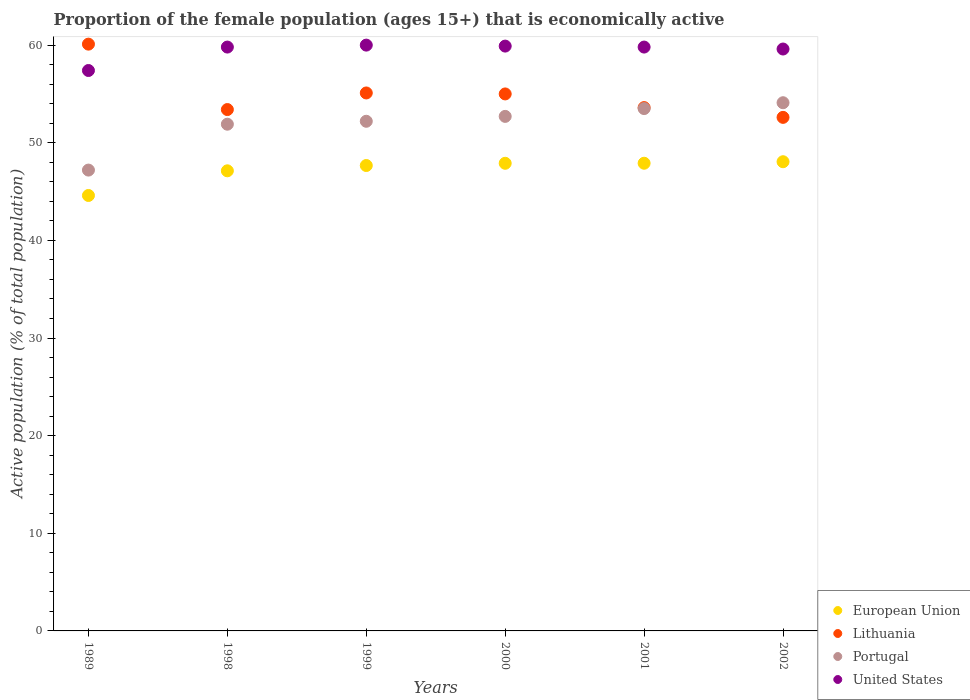Is the number of dotlines equal to the number of legend labels?
Offer a terse response. Yes. What is the proportion of the female population that is economically active in Lithuania in 2000?
Your answer should be compact. 55. Across all years, what is the minimum proportion of the female population that is economically active in Lithuania?
Your response must be concise. 52.6. In which year was the proportion of the female population that is economically active in European Union minimum?
Your response must be concise. 1989. What is the total proportion of the female population that is economically active in Portugal in the graph?
Your answer should be compact. 311.6. What is the difference between the proportion of the female population that is economically active in European Union in 1999 and that in 2000?
Give a very brief answer. -0.23. What is the difference between the proportion of the female population that is economically active in Portugal in 2001 and the proportion of the female population that is economically active in European Union in 2000?
Ensure brevity in your answer.  5.6. What is the average proportion of the female population that is economically active in European Union per year?
Keep it short and to the point. 47.21. In the year 2000, what is the difference between the proportion of the female population that is economically active in Portugal and proportion of the female population that is economically active in Lithuania?
Provide a succinct answer. -2.3. What is the ratio of the proportion of the female population that is economically active in United States in 1989 to that in 2002?
Offer a very short reply. 0.96. What is the difference between the highest and the second highest proportion of the female population that is economically active in Portugal?
Keep it short and to the point. 0.6. What is the difference between the highest and the lowest proportion of the female population that is economically active in Portugal?
Your response must be concise. 6.9. Is it the case that in every year, the sum of the proportion of the female population that is economically active in Lithuania and proportion of the female population that is economically active in United States  is greater than the sum of proportion of the female population that is economically active in Portugal and proportion of the female population that is economically active in European Union?
Ensure brevity in your answer.  No. Is it the case that in every year, the sum of the proportion of the female population that is economically active in European Union and proportion of the female population that is economically active in Portugal  is greater than the proportion of the female population that is economically active in Lithuania?
Your answer should be compact. Yes. Is the proportion of the female population that is economically active in United States strictly greater than the proportion of the female population that is economically active in Lithuania over the years?
Ensure brevity in your answer.  No. Is the proportion of the female population that is economically active in Lithuania strictly less than the proportion of the female population that is economically active in European Union over the years?
Your response must be concise. No. How many dotlines are there?
Make the answer very short. 4. Are the values on the major ticks of Y-axis written in scientific E-notation?
Make the answer very short. No. Does the graph contain grids?
Make the answer very short. No. How many legend labels are there?
Your response must be concise. 4. How are the legend labels stacked?
Provide a succinct answer. Vertical. What is the title of the graph?
Provide a short and direct response. Proportion of the female population (ages 15+) that is economically active. Does "Bahrain" appear as one of the legend labels in the graph?
Your response must be concise. No. What is the label or title of the Y-axis?
Ensure brevity in your answer.  Active population (% of total population). What is the Active population (% of total population) in European Union in 1989?
Your answer should be very brief. 44.6. What is the Active population (% of total population) of Lithuania in 1989?
Offer a very short reply. 60.1. What is the Active population (% of total population) of Portugal in 1989?
Make the answer very short. 47.2. What is the Active population (% of total population) of United States in 1989?
Keep it short and to the point. 57.4. What is the Active population (% of total population) in European Union in 1998?
Provide a short and direct response. 47.13. What is the Active population (% of total population) in Lithuania in 1998?
Provide a short and direct response. 53.4. What is the Active population (% of total population) in Portugal in 1998?
Provide a short and direct response. 51.9. What is the Active population (% of total population) in United States in 1998?
Ensure brevity in your answer.  59.8. What is the Active population (% of total population) of European Union in 1999?
Offer a very short reply. 47.67. What is the Active population (% of total population) in Lithuania in 1999?
Give a very brief answer. 55.1. What is the Active population (% of total population) in Portugal in 1999?
Your response must be concise. 52.2. What is the Active population (% of total population) in European Union in 2000?
Offer a very short reply. 47.9. What is the Active population (% of total population) of Portugal in 2000?
Your response must be concise. 52.7. What is the Active population (% of total population) in United States in 2000?
Offer a very short reply. 59.9. What is the Active population (% of total population) in European Union in 2001?
Keep it short and to the point. 47.9. What is the Active population (% of total population) in Lithuania in 2001?
Provide a short and direct response. 53.6. What is the Active population (% of total population) in Portugal in 2001?
Your answer should be compact. 53.5. What is the Active population (% of total population) in United States in 2001?
Give a very brief answer. 59.8. What is the Active population (% of total population) of European Union in 2002?
Provide a succinct answer. 48.06. What is the Active population (% of total population) of Lithuania in 2002?
Provide a succinct answer. 52.6. What is the Active population (% of total population) of Portugal in 2002?
Provide a succinct answer. 54.1. What is the Active population (% of total population) in United States in 2002?
Provide a short and direct response. 59.6. Across all years, what is the maximum Active population (% of total population) of European Union?
Your answer should be very brief. 48.06. Across all years, what is the maximum Active population (% of total population) of Lithuania?
Provide a short and direct response. 60.1. Across all years, what is the maximum Active population (% of total population) in Portugal?
Provide a succinct answer. 54.1. Across all years, what is the minimum Active population (% of total population) of European Union?
Your answer should be compact. 44.6. Across all years, what is the minimum Active population (% of total population) of Lithuania?
Your response must be concise. 52.6. Across all years, what is the minimum Active population (% of total population) in Portugal?
Give a very brief answer. 47.2. Across all years, what is the minimum Active population (% of total population) of United States?
Make the answer very short. 57.4. What is the total Active population (% of total population) in European Union in the graph?
Offer a terse response. 283.25. What is the total Active population (% of total population) in Lithuania in the graph?
Offer a terse response. 329.8. What is the total Active population (% of total population) of Portugal in the graph?
Offer a very short reply. 311.6. What is the total Active population (% of total population) of United States in the graph?
Offer a terse response. 356.5. What is the difference between the Active population (% of total population) in European Union in 1989 and that in 1998?
Keep it short and to the point. -2.53. What is the difference between the Active population (% of total population) in European Union in 1989 and that in 1999?
Make the answer very short. -3.07. What is the difference between the Active population (% of total population) of Portugal in 1989 and that in 1999?
Your answer should be very brief. -5. What is the difference between the Active population (% of total population) of European Union in 1989 and that in 2000?
Your response must be concise. -3.3. What is the difference between the Active population (% of total population) of Lithuania in 1989 and that in 2000?
Your answer should be compact. 5.1. What is the difference between the Active population (% of total population) of Portugal in 1989 and that in 2000?
Offer a very short reply. -5.5. What is the difference between the Active population (% of total population) of European Union in 1989 and that in 2001?
Ensure brevity in your answer.  -3.3. What is the difference between the Active population (% of total population) of United States in 1989 and that in 2001?
Give a very brief answer. -2.4. What is the difference between the Active population (% of total population) of European Union in 1989 and that in 2002?
Your answer should be very brief. -3.46. What is the difference between the Active population (% of total population) of Lithuania in 1989 and that in 2002?
Provide a short and direct response. 7.5. What is the difference between the Active population (% of total population) of European Union in 1998 and that in 1999?
Give a very brief answer. -0.54. What is the difference between the Active population (% of total population) of Portugal in 1998 and that in 1999?
Make the answer very short. -0.3. What is the difference between the Active population (% of total population) of European Union in 1998 and that in 2000?
Your answer should be compact. -0.77. What is the difference between the Active population (% of total population) in Lithuania in 1998 and that in 2000?
Your response must be concise. -1.6. What is the difference between the Active population (% of total population) of Portugal in 1998 and that in 2000?
Your answer should be compact. -0.8. What is the difference between the Active population (% of total population) in European Union in 1998 and that in 2001?
Make the answer very short. -0.78. What is the difference between the Active population (% of total population) in United States in 1998 and that in 2001?
Your response must be concise. 0. What is the difference between the Active population (% of total population) in European Union in 1998 and that in 2002?
Offer a terse response. -0.93. What is the difference between the Active population (% of total population) in European Union in 1999 and that in 2000?
Give a very brief answer. -0.23. What is the difference between the Active population (% of total population) in Lithuania in 1999 and that in 2000?
Your answer should be very brief. 0.1. What is the difference between the Active population (% of total population) in European Union in 1999 and that in 2001?
Offer a terse response. -0.23. What is the difference between the Active population (% of total population) of Portugal in 1999 and that in 2001?
Offer a terse response. -1.3. What is the difference between the Active population (% of total population) in European Union in 1999 and that in 2002?
Provide a succinct answer. -0.39. What is the difference between the Active population (% of total population) of Lithuania in 1999 and that in 2002?
Your answer should be very brief. 2.5. What is the difference between the Active population (% of total population) of Portugal in 1999 and that in 2002?
Offer a very short reply. -1.9. What is the difference between the Active population (% of total population) in United States in 1999 and that in 2002?
Keep it short and to the point. 0.4. What is the difference between the Active population (% of total population) of European Union in 2000 and that in 2001?
Provide a succinct answer. -0.01. What is the difference between the Active population (% of total population) in Portugal in 2000 and that in 2001?
Your answer should be very brief. -0.8. What is the difference between the Active population (% of total population) of European Union in 2000 and that in 2002?
Give a very brief answer. -0.16. What is the difference between the Active population (% of total population) of European Union in 2001 and that in 2002?
Provide a succinct answer. -0.16. What is the difference between the Active population (% of total population) of Lithuania in 2001 and that in 2002?
Offer a very short reply. 1. What is the difference between the Active population (% of total population) of Portugal in 2001 and that in 2002?
Offer a terse response. -0.6. What is the difference between the Active population (% of total population) of European Union in 1989 and the Active population (% of total population) of Lithuania in 1998?
Offer a terse response. -8.8. What is the difference between the Active population (% of total population) in European Union in 1989 and the Active population (% of total population) in Portugal in 1998?
Offer a terse response. -7.3. What is the difference between the Active population (% of total population) of European Union in 1989 and the Active population (% of total population) of United States in 1998?
Provide a succinct answer. -15.2. What is the difference between the Active population (% of total population) in Lithuania in 1989 and the Active population (% of total population) in United States in 1998?
Provide a succinct answer. 0.3. What is the difference between the Active population (% of total population) in Portugal in 1989 and the Active population (% of total population) in United States in 1998?
Your answer should be compact. -12.6. What is the difference between the Active population (% of total population) in European Union in 1989 and the Active population (% of total population) in Lithuania in 1999?
Give a very brief answer. -10.5. What is the difference between the Active population (% of total population) of European Union in 1989 and the Active population (% of total population) of Portugal in 1999?
Offer a terse response. -7.6. What is the difference between the Active population (% of total population) of European Union in 1989 and the Active population (% of total population) of United States in 1999?
Provide a succinct answer. -15.4. What is the difference between the Active population (% of total population) in Lithuania in 1989 and the Active population (% of total population) in United States in 1999?
Offer a terse response. 0.1. What is the difference between the Active population (% of total population) of European Union in 1989 and the Active population (% of total population) of Lithuania in 2000?
Your answer should be compact. -10.4. What is the difference between the Active population (% of total population) in European Union in 1989 and the Active population (% of total population) in Portugal in 2000?
Your response must be concise. -8.1. What is the difference between the Active population (% of total population) of European Union in 1989 and the Active population (% of total population) of United States in 2000?
Give a very brief answer. -15.3. What is the difference between the Active population (% of total population) of Lithuania in 1989 and the Active population (% of total population) of Portugal in 2000?
Provide a short and direct response. 7.4. What is the difference between the Active population (% of total population) of Lithuania in 1989 and the Active population (% of total population) of United States in 2000?
Provide a short and direct response. 0.2. What is the difference between the Active population (% of total population) of European Union in 1989 and the Active population (% of total population) of Lithuania in 2001?
Give a very brief answer. -9. What is the difference between the Active population (% of total population) of European Union in 1989 and the Active population (% of total population) of Portugal in 2001?
Give a very brief answer. -8.9. What is the difference between the Active population (% of total population) in European Union in 1989 and the Active population (% of total population) in United States in 2001?
Your answer should be very brief. -15.2. What is the difference between the Active population (% of total population) of Lithuania in 1989 and the Active population (% of total population) of Portugal in 2001?
Keep it short and to the point. 6.6. What is the difference between the Active population (% of total population) of Portugal in 1989 and the Active population (% of total population) of United States in 2001?
Your answer should be very brief. -12.6. What is the difference between the Active population (% of total population) in European Union in 1989 and the Active population (% of total population) in Lithuania in 2002?
Provide a succinct answer. -8. What is the difference between the Active population (% of total population) in European Union in 1989 and the Active population (% of total population) in Portugal in 2002?
Your answer should be very brief. -9.5. What is the difference between the Active population (% of total population) in European Union in 1989 and the Active population (% of total population) in United States in 2002?
Provide a succinct answer. -15. What is the difference between the Active population (% of total population) of Lithuania in 1989 and the Active population (% of total population) of Portugal in 2002?
Your answer should be compact. 6. What is the difference between the Active population (% of total population) in Lithuania in 1989 and the Active population (% of total population) in United States in 2002?
Offer a terse response. 0.5. What is the difference between the Active population (% of total population) of Portugal in 1989 and the Active population (% of total population) of United States in 2002?
Provide a succinct answer. -12.4. What is the difference between the Active population (% of total population) in European Union in 1998 and the Active population (% of total population) in Lithuania in 1999?
Give a very brief answer. -7.97. What is the difference between the Active population (% of total population) in European Union in 1998 and the Active population (% of total population) in Portugal in 1999?
Offer a terse response. -5.07. What is the difference between the Active population (% of total population) of European Union in 1998 and the Active population (% of total population) of United States in 1999?
Your response must be concise. -12.87. What is the difference between the Active population (% of total population) of Lithuania in 1998 and the Active population (% of total population) of United States in 1999?
Provide a short and direct response. -6.6. What is the difference between the Active population (% of total population) of European Union in 1998 and the Active population (% of total population) of Lithuania in 2000?
Make the answer very short. -7.87. What is the difference between the Active population (% of total population) of European Union in 1998 and the Active population (% of total population) of Portugal in 2000?
Make the answer very short. -5.57. What is the difference between the Active population (% of total population) of European Union in 1998 and the Active population (% of total population) of United States in 2000?
Make the answer very short. -12.77. What is the difference between the Active population (% of total population) in Lithuania in 1998 and the Active population (% of total population) in United States in 2000?
Your answer should be compact. -6.5. What is the difference between the Active population (% of total population) of Portugal in 1998 and the Active population (% of total population) of United States in 2000?
Keep it short and to the point. -8. What is the difference between the Active population (% of total population) in European Union in 1998 and the Active population (% of total population) in Lithuania in 2001?
Give a very brief answer. -6.47. What is the difference between the Active population (% of total population) of European Union in 1998 and the Active population (% of total population) of Portugal in 2001?
Your answer should be very brief. -6.37. What is the difference between the Active population (% of total population) of European Union in 1998 and the Active population (% of total population) of United States in 2001?
Offer a terse response. -12.67. What is the difference between the Active population (% of total population) in Portugal in 1998 and the Active population (% of total population) in United States in 2001?
Offer a terse response. -7.9. What is the difference between the Active population (% of total population) in European Union in 1998 and the Active population (% of total population) in Lithuania in 2002?
Keep it short and to the point. -5.47. What is the difference between the Active population (% of total population) of European Union in 1998 and the Active population (% of total population) of Portugal in 2002?
Give a very brief answer. -6.97. What is the difference between the Active population (% of total population) of European Union in 1998 and the Active population (% of total population) of United States in 2002?
Give a very brief answer. -12.47. What is the difference between the Active population (% of total population) in Lithuania in 1998 and the Active population (% of total population) in Portugal in 2002?
Your answer should be very brief. -0.7. What is the difference between the Active population (% of total population) of Lithuania in 1998 and the Active population (% of total population) of United States in 2002?
Your response must be concise. -6.2. What is the difference between the Active population (% of total population) of Portugal in 1998 and the Active population (% of total population) of United States in 2002?
Provide a succinct answer. -7.7. What is the difference between the Active population (% of total population) of European Union in 1999 and the Active population (% of total population) of Lithuania in 2000?
Your answer should be compact. -7.33. What is the difference between the Active population (% of total population) in European Union in 1999 and the Active population (% of total population) in Portugal in 2000?
Provide a short and direct response. -5.03. What is the difference between the Active population (% of total population) of European Union in 1999 and the Active population (% of total population) of United States in 2000?
Ensure brevity in your answer.  -12.23. What is the difference between the Active population (% of total population) of Lithuania in 1999 and the Active population (% of total population) of United States in 2000?
Ensure brevity in your answer.  -4.8. What is the difference between the Active population (% of total population) in European Union in 1999 and the Active population (% of total population) in Lithuania in 2001?
Offer a terse response. -5.93. What is the difference between the Active population (% of total population) in European Union in 1999 and the Active population (% of total population) in Portugal in 2001?
Provide a short and direct response. -5.83. What is the difference between the Active population (% of total population) of European Union in 1999 and the Active population (% of total population) of United States in 2001?
Provide a short and direct response. -12.13. What is the difference between the Active population (% of total population) in European Union in 1999 and the Active population (% of total population) in Lithuania in 2002?
Offer a very short reply. -4.93. What is the difference between the Active population (% of total population) in European Union in 1999 and the Active population (% of total population) in Portugal in 2002?
Offer a terse response. -6.43. What is the difference between the Active population (% of total population) in European Union in 1999 and the Active population (% of total population) in United States in 2002?
Ensure brevity in your answer.  -11.93. What is the difference between the Active population (% of total population) in Lithuania in 1999 and the Active population (% of total population) in Portugal in 2002?
Give a very brief answer. 1. What is the difference between the Active population (% of total population) of European Union in 2000 and the Active population (% of total population) of Lithuania in 2001?
Your answer should be very brief. -5.7. What is the difference between the Active population (% of total population) in European Union in 2000 and the Active population (% of total population) in Portugal in 2001?
Provide a succinct answer. -5.6. What is the difference between the Active population (% of total population) in European Union in 2000 and the Active population (% of total population) in United States in 2001?
Offer a terse response. -11.9. What is the difference between the Active population (% of total population) of Lithuania in 2000 and the Active population (% of total population) of United States in 2001?
Keep it short and to the point. -4.8. What is the difference between the Active population (% of total population) in Portugal in 2000 and the Active population (% of total population) in United States in 2001?
Offer a terse response. -7.1. What is the difference between the Active population (% of total population) of European Union in 2000 and the Active population (% of total population) of Lithuania in 2002?
Provide a succinct answer. -4.7. What is the difference between the Active population (% of total population) of European Union in 2000 and the Active population (% of total population) of Portugal in 2002?
Make the answer very short. -6.2. What is the difference between the Active population (% of total population) of European Union in 2000 and the Active population (% of total population) of United States in 2002?
Offer a very short reply. -11.7. What is the difference between the Active population (% of total population) in Portugal in 2000 and the Active population (% of total population) in United States in 2002?
Offer a very short reply. -6.9. What is the difference between the Active population (% of total population) of European Union in 2001 and the Active population (% of total population) of Lithuania in 2002?
Your response must be concise. -4.7. What is the difference between the Active population (% of total population) of European Union in 2001 and the Active population (% of total population) of Portugal in 2002?
Make the answer very short. -6.2. What is the difference between the Active population (% of total population) in European Union in 2001 and the Active population (% of total population) in United States in 2002?
Provide a short and direct response. -11.7. What is the difference between the Active population (% of total population) in Lithuania in 2001 and the Active population (% of total population) in Portugal in 2002?
Make the answer very short. -0.5. What is the difference between the Active population (% of total population) of Portugal in 2001 and the Active population (% of total population) of United States in 2002?
Make the answer very short. -6.1. What is the average Active population (% of total population) in European Union per year?
Ensure brevity in your answer.  47.21. What is the average Active population (% of total population) in Lithuania per year?
Give a very brief answer. 54.97. What is the average Active population (% of total population) of Portugal per year?
Make the answer very short. 51.93. What is the average Active population (% of total population) in United States per year?
Make the answer very short. 59.42. In the year 1989, what is the difference between the Active population (% of total population) in European Union and Active population (% of total population) in Lithuania?
Keep it short and to the point. -15.5. In the year 1989, what is the difference between the Active population (% of total population) in European Union and Active population (% of total population) in Portugal?
Provide a succinct answer. -2.6. In the year 1989, what is the difference between the Active population (% of total population) of European Union and Active population (% of total population) of United States?
Your answer should be compact. -12.8. In the year 1989, what is the difference between the Active population (% of total population) in Lithuania and Active population (% of total population) in Portugal?
Your answer should be compact. 12.9. In the year 1989, what is the difference between the Active population (% of total population) of Portugal and Active population (% of total population) of United States?
Ensure brevity in your answer.  -10.2. In the year 1998, what is the difference between the Active population (% of total population) in European Union and Active population (% of total population) in Lithuania?
Provide a succinct answer. -6.27. In the year 1998, what is the difference between the Active population (% of total population) in European Union and Active population (% of total population) in Portugal?
Ensure brevity in your answer.  -4.77. In the year 1998, what is the difference between the Active population (% of total population) in European Union and Active population (% of total population) in United States?
Make the answer very short. -12.67. In the year 1998, what is the difference between the Active population (% of total population) in Lithuania and Active population (% of total population) in Portugal?
Your answer should be very brief. 1.5. In the year 1999, what is the difference between the Active population (% of total population) in European Union and Active population (% of total population) in Lithuania?
Offer a very short reply. -7.43. In the year 1999, what is the difference between the Active population (% of total population) of European Union and Active population (% of total population) of Portugal?
Your response must be concise. -4.53. In the year 1999, what is the difference between the Active population (% of total population) in European Union and Active population (% of total population) in United States?
Make the answer very short. -12.33. In the year 1999, what is the difference between the Active population (% of total population) of Lithuania and Active population (% of total population) of United States?
Offer a very short reply. -4.9. In the year 1999, what is the difference between the Active population (% of total population) in Portugal and Active population (% of total population) in United States?
Make the answer very short. -7.8. In the year 2000, what is the difference between the Active population (% of total population) of European Union and Active population (% of total population) of Lithuania?
Offer a very short reply. -7.1. In the year 2000, what is the difference between the Active population (% of total population) in European Union and Active population (% of total population) in Portugal?
Your answer should be very brief. -4.8. In the year 2000, what is the difference between the Active population (% of total population) of European Union and Active population (% of total population) of United States?
Provide a succinct answer. -12. In the year 2000, what is the difference between the Active population (% of total population) of Lithuania and Active population (% of total population) of United States?
Keep it short and to the point. -4.9. In the year 2001, what is the difference between the Active population (% of total population) of European Union and Active population (% of total population) of Lithuania?
Your answer should be compact. -5.7. In the year 2001, what is the difference between the Active population (% of total population) of European Union and Active population (% of total population) of Portugal?
Keep it short and to the point. -5.6. In the year 2001, what is the difference between the Active population (% of total population) of European Union and Active population (% of total population) of United States?
Give a very brief answer. -11.9. In the year 2001, what is the difference between the Active population (% of total population) in Lithuania and Active population (% of total population) in Portugal?
Your response must be concise. 0.1. In the year 2001, what is the difference between the Active population (% of total population) of Lithuania and Active population (% of total population) of United States?
Your response must be concise. -6.2. In the year 2002, what is the difference between the Active population (% of total population) of European Union and Active population (% of total population) of Lithuania?
Offer a very short reply. -4.54. In the year 2002, what is the difference between the Active population (% of total population) of European Union and Active population (% of total population) of Portugal?
Make the answer very short. -6.04. In the year 2002, what is the difference between the Active population (% of total population) in European Union and Active population (% of total population) in United States?
Your answer should be very brief. -11.54. In the year 2002, what is the difference between the Active population (% of total population) of Lithuania and Active population (% of total population) of United States?
Offer a terse response. -7. What is the ratio of the Active population (% of total population) in European Union in 1989 to that in 1998?
Offer a terse response. 0.95. What is the ratio of the Active population (% of total population) of Lithuania in 1989 to that in 1998?
Your answer should be compact. 1.13. What is the ratio of the Active population (% of total population) in Portugal in 1989 to that in 1998?
Provide a succinct answer. 0.91. What is the ratio of the Active population (% of total population) in United States in 1989 to that in 1998?
Give a very brief answer. 0.96. What is the ratio of the Active population (% of total population) in European Union in 1989 to that in 1999?
Provide a short and direct response. 0.94. What is the ratio of the Active population (% of total population) of Lithuania in 1989 to that in 1999?
Provide a succinct answer. 1.09. What is the ratio of the Active population (% of total population) in Portugal in 1989 to that in 1999?
Offer a terse response. 0.9. What is the ratio of the Active population (% of total population) in United States in 1989 to that in 1999?
Make the answer very short. 0.96. What is the ratio of the Active population (% of total population) in European Union in 1989 to that in 2000?
Your answer should be compact. 0.93. What is the ratio of the Active population (% of total population) of Lithuania in 1989 to that in 2000?
Provide a succinct answer. 1.09. What is the ratio of the Active population (% of total population) of Portugal in 1989 to that in 2000?
Give a very brief answer. 0.9. What is the ratio of the Active population (% of total population) of European Union in 1989 to that in 2001?
Your response must be concise. 0.93. What is the ratio of the Active population (% of total population) in Lithuania in 1989 to that in 2001?
Provide a succinct answer. 1.12. What is the ratio of the Active population (% of total population) of Portugal in 1989 to that in 2001?
Offer a very short reply. 0.88. What is the ratio of the Active population (% of total population) of United States in 1989 to that in 2001?
Keep it short and to the point. 0.96. What is the ratio of the Active population (% of total population) of European Union in 1989 to that in 2002?
Provide a short and direct response. 0.93. What is the ratio of the Active population (% of total population) in Lithuania in 1989 to that in 2002?
Provide a succinct answer. 1.14. What is the ratio of the Active population (% of total population) of Portugal in 1989 to that in 2002?
Your answer should be compact. 0.87. What is the ratio of the Active population (% of total population) in United States in 1989 to that in 2002?
Your response must be concise. 0.96. What is the ratio of the Active population (% of total population) of European Union in 1998 to that in 1999?
Your answer should be very brief. 0.99. What is the ratio of the Active population (% of total population) of Lithuania in 1998 to that in 1999?
Offer a very short reply. 0.97. What is the ratio of the Active population (% of total population) in European Union in 1998 to that in 2000?
Your response must be concise. 0.98. What is the ratio of the Active population (% of total population) of Lithuania in 1998 to that in 2000?
Give a very brief answer. 0.97. What is the ratio of the Active population (% of total population) of United States in 1998 to that in 2000?
Your response must be concise. 1. What is the ratio of the Active population (% of total population) in European Union in 1998 to that in 2001?
Your answer should be compact. 0.98. What is the ratio of the Active population (% of total population) of Lithuania in 1998 to that in 2001?
Offer a terse response. 1. What is the ratio of the Active population (% of total population) of Portugal in 1998 to that in 2001?
Your answer should be very brief. 0.97. What is the ratio of the Active population (% of total population) in European Union in 1998 to that in 2002?
Ensure brevity in your answer.  0.98. What is the ratio of the Active population (% of total population) in Lithuania in 1998 to that in 2002?
Offer a terse response. 1.02. What is the ratio of the Active population (% of total population) of Portugal in 1998 to that in 2002?
Provide a short and direct response. 0.96. What is the ratio of the Active population (% of total population) in United States in 1998 to that in 2002?
Your answer should be compact. 1. What is the ratio of the Active population (% of total population) in United States in 1999 to that in 2000?
Provide a short and direct response. 1. What is the ratio of the Active population (% of total population) in European Union in 1999 to that in 2001?
Your answer should be compact. 1. What is the ratio of the Active population (% of total population) in Lithuania in 1999 to that in 2001?
Make the answer very short. 1.03. What is the ratio of the Active population (% of total population) in Portugal in 1999 to that in 2001?
Your response must be concise. 0.98. What is the ratio of the Active population (% of total population) of United States in 1999 to that in 2001?
Your response must be concise. 1. What is the ratio of the Active population (% of total population) of European Union in 1999 to that in 2002?
Offer a terse response. 0.99. What is the ratio of the Active population (% of total population) in Lithuania in 1999 to that in 2002?
Ensure brevity in your answer.  1.05. What is the ratio of the Active population (% of total population) in Portugal in 1999 to that in 2002?
Your response must be concise. 0.96. What is the ratio of the Active population (% of total population) of United States in 1999 to that in 2002?
Your answer should be compact. 1.01. What is the ratio of the Active population (% of total population) of European Union in 2000 to that in 2001?
Keep it short and to the point. 1. What is the ratio of the Active population (% of total population) of Lithuania in 2000 to that in 2001?
Give a very brief answer. 1.03. What is the ratio of the Active population (% of total population) of Portugal in 2000 to that in 2001?
Keep it short and to the point. 0.98. What is the ratio of the Active population (% of total population) in Lithuania in 2000 to that in 2002?
Your answer should be very brief. 1.05. What is the ratio of the Active population (% of total population) in Portugal in 2000 to that in 2002?
Your answer should be very brief. 0.97. What is the ratio of the Active population (% of total population) in European Union in 2001 to that in 2002?
Ensure brevity in your answer.  1. What is the ratio of the Active population (% of total population) in Portugal in 2001 to that in 2002?
Provide a succinct answer. 0.99. What is the ratio of the Active population (% of total population) in United States in 2001 to that in 2002?
Your response must be concise. 1. What is the difference between the highest and the second highest Active population (% of total population) in European Union?
Offer a terse response. 0.16. What is the difference between the highest and the second highest Active population (% of total population) in Lithuania?
Offer a very short reply. 5. What is the difference between the highest and the second highest Active population (% of total population) of Portugal?
Provide a succinct answer. 0.6. What is the difference between the highest and the lowest Active population (% of total population) of European Union?
Your response must be concise. 3.46. What is the difference between the highest and the lowest Active population (% of total population) in Lithuania?
Keep it short and to the point. 7.5. 